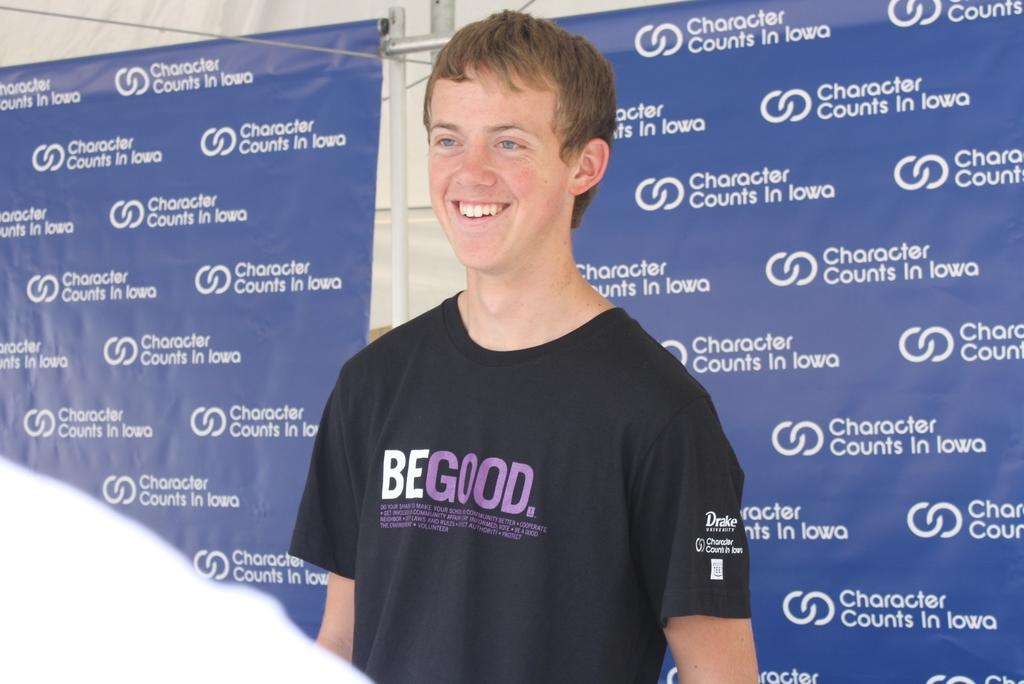<image>
Provide a brief description of the given image. man wearing black begood shirt  against background that has character counts in iowa all over it 